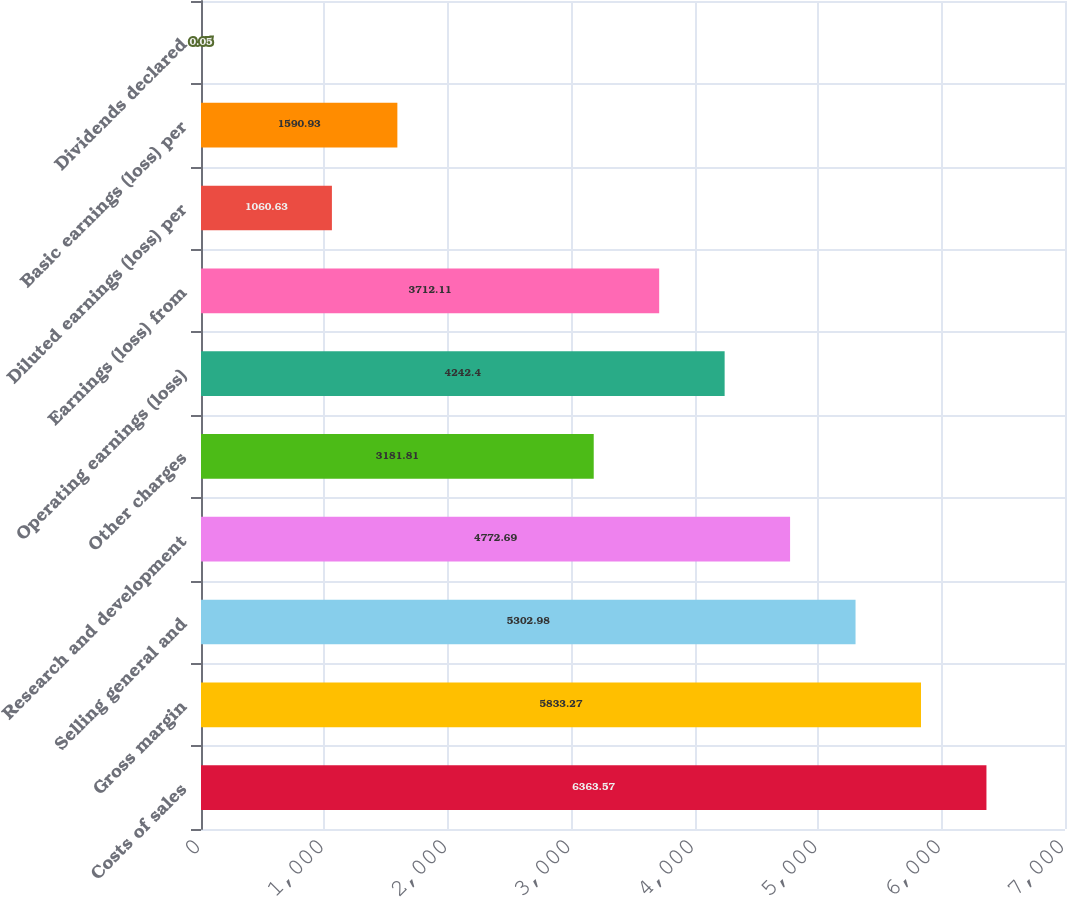Convert chart to OTSL. <chart><loc_0><loc_0><loc_500><loc_500><bar_chart><fcel>Costs of sales<fcel>Gross margin<fcel>Selling general and<fcel>Research and development<fcel>Other charges<fcel>Operating earnings (loss)<fcel>Earnings (loss) from<fcel>Diluted earnings (loss) per<fcel>Basic earnings (loss) per<fcel>Dividends declared<nl><fcel>6363.57<fcel>5833.27<fcel>5302.98<fcel>4772.69<fcel>3181.81<fcel>4242.4<fcel>3712.11<fcel>1060.63<fcel>1590.93<fcel>0.05<nl></chart> 